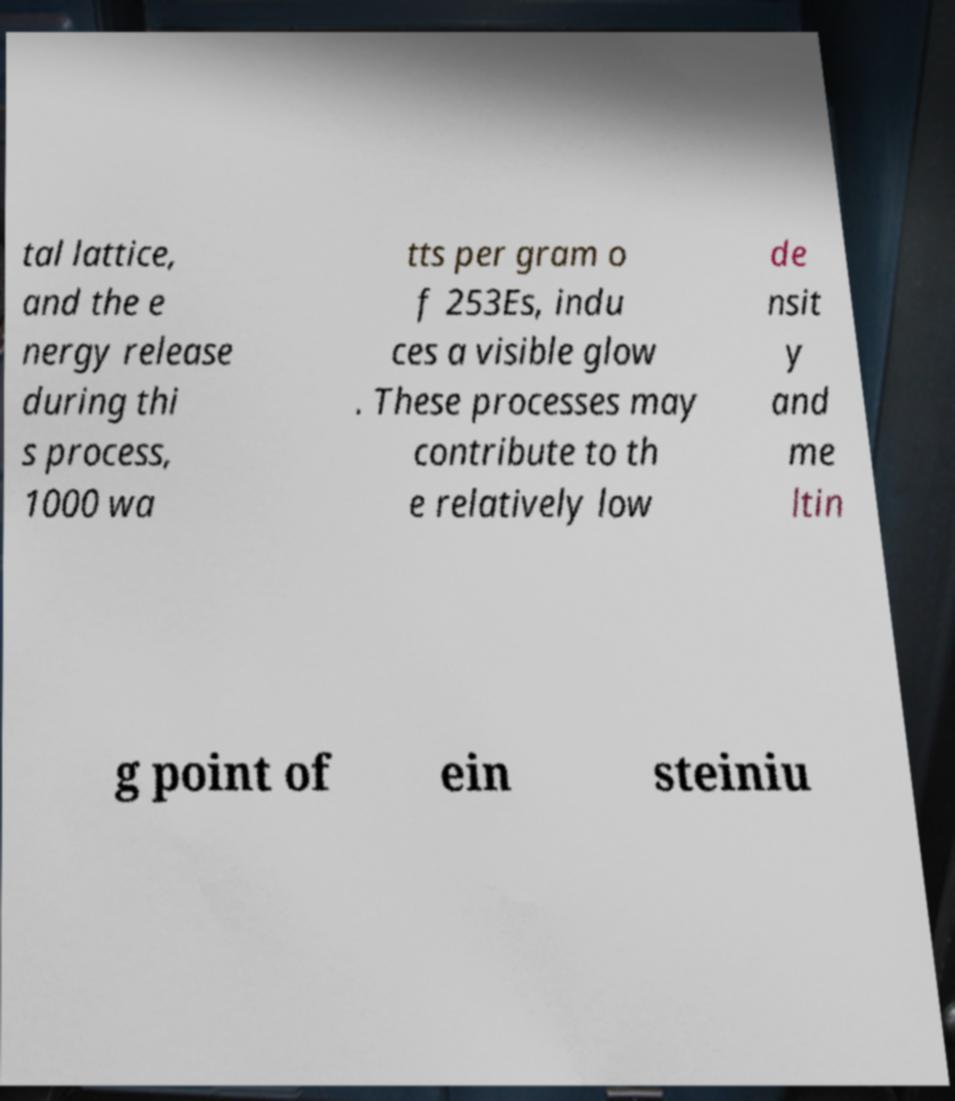Can you read and provide the text displayed in the image?This photo seems to have some interesting text. Can you extract and type it out for me? tal lattice, and the e nergy release during thi s process, 1000 wa tts per gram o f 253Es, indu ces a visible glow . These processes may contribute to th e relatively low de nsit y and me ltin g point of ein steiniu 